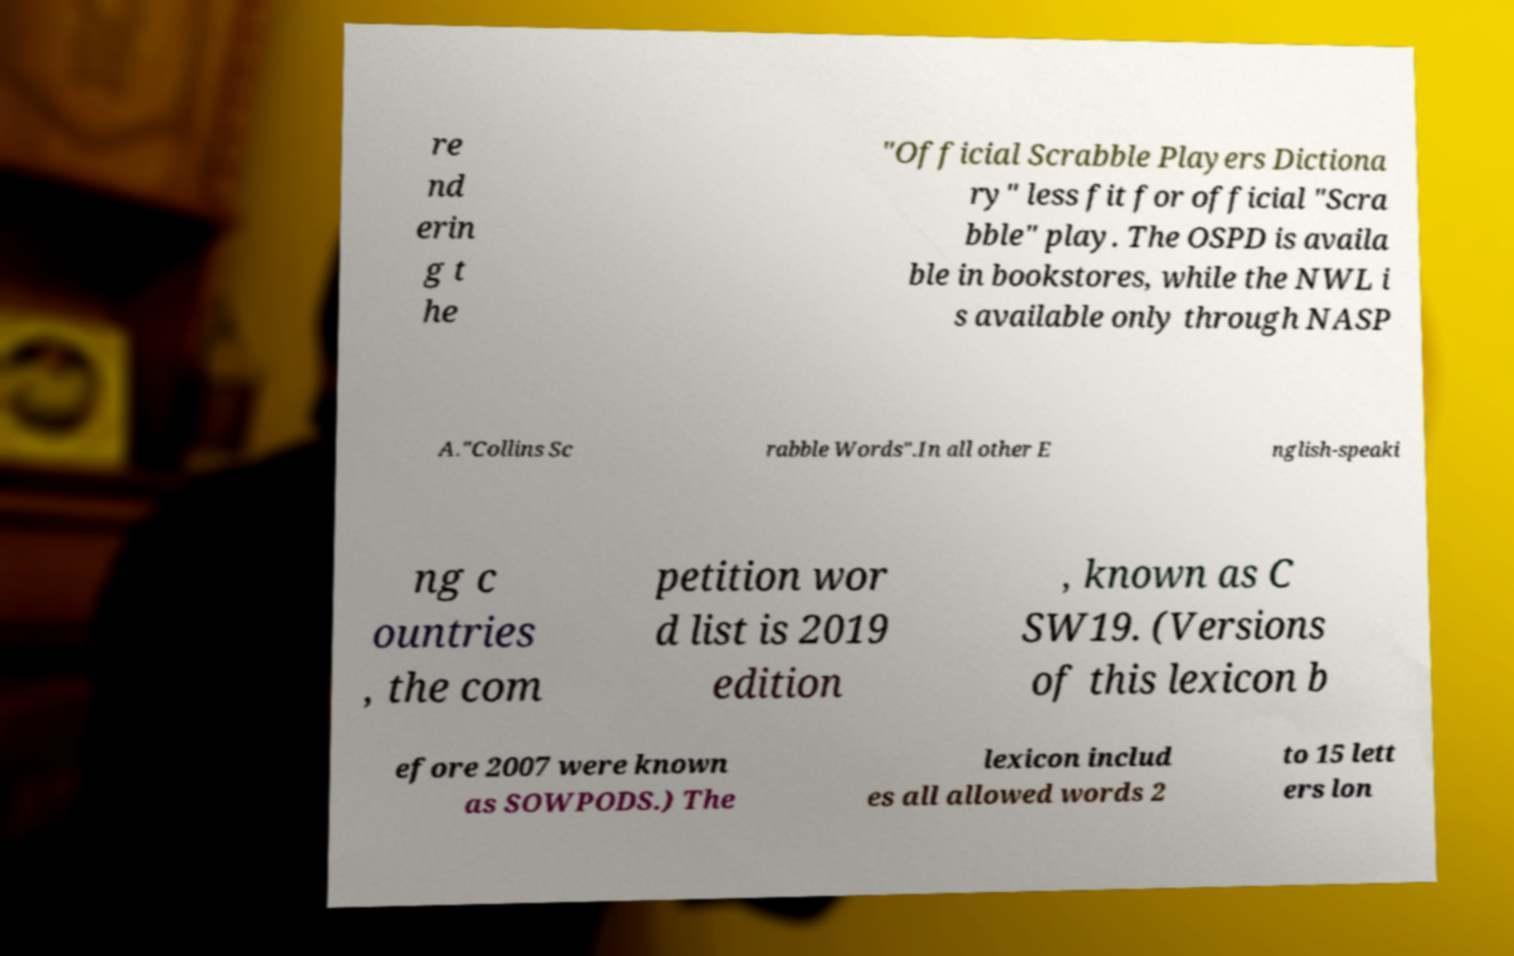I need the written content from this picture converted into text. Can you do that? re nd erin g t he "Official Scrabble Players Dictiona ry" less fit for official "Scra bble" play. The OSPD is availa ble in bookstores, while the NWL i s available only through NASP A."Collins Sc rabble Words".In all other E nglish-speaki ng c ountries , the com petition wor d list is 2019 edition , known as C SW19. (Versions of this lexicon b efore 2007 were known as SOWPODS.) The lexicon includ es all allowed words 2 to 15 lett ers lon 